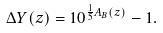<formula> <loc_0><loc_0><loc_500><loc_500>\Delta { Y } ( z ) = 1 0 ^ { \frac { 1 } { 5 } A _ { B } ( z ) } - 1 .</formula> 